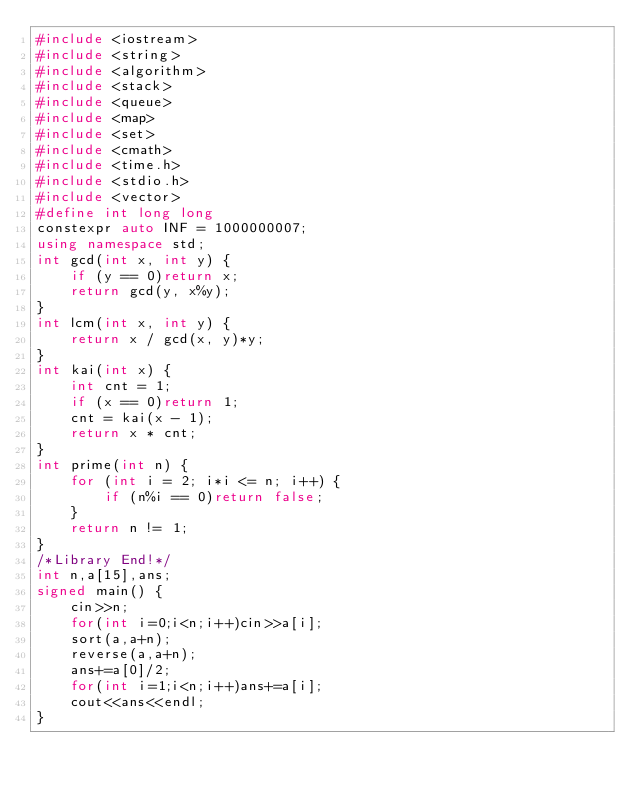<code> <loc_0><loc_0><loc_500><loc_500><_C++_>#include <iostream>
#include <string>
#include <algorithm>
#include <stack>
#include <queue>
#include <map>
#include <set>
#include <cmath>
#include <time.h>
#include <stdio.h>
#include <vector>
#define int long long
constexpr auto INF = 1000000007;
using namespace std;
int gcd(int x, int y) {
    if (y == 0)return x;
    return gcd(y, x%y);
}
int lcm(int x, int y) {
    return x / gcd(x, y)*y;
}
int kai(int x) {
    int cnt = 1;
    if (x == 0)return 1;
    cnt = kai(x - 1);
    return x * cnt;
}
int prime(int n) {
    for (int i = 2; i*i <= n; i++) {
        if (n%i == 0)return false;
    }
    return n != 1;
}
/*Library End!*/
int n,a[15],ans;
signed main() {
    cin>>n;
    for(int i=0;i<n;i++)cin>>a[i];
    sort(a,a+n);
    reverse(a,a+n);
    ans+=a[0]/2;
    for(int i=1;i<n;i++)ans+=a[i];
    cout<<ans<<endl;
}
</code> 